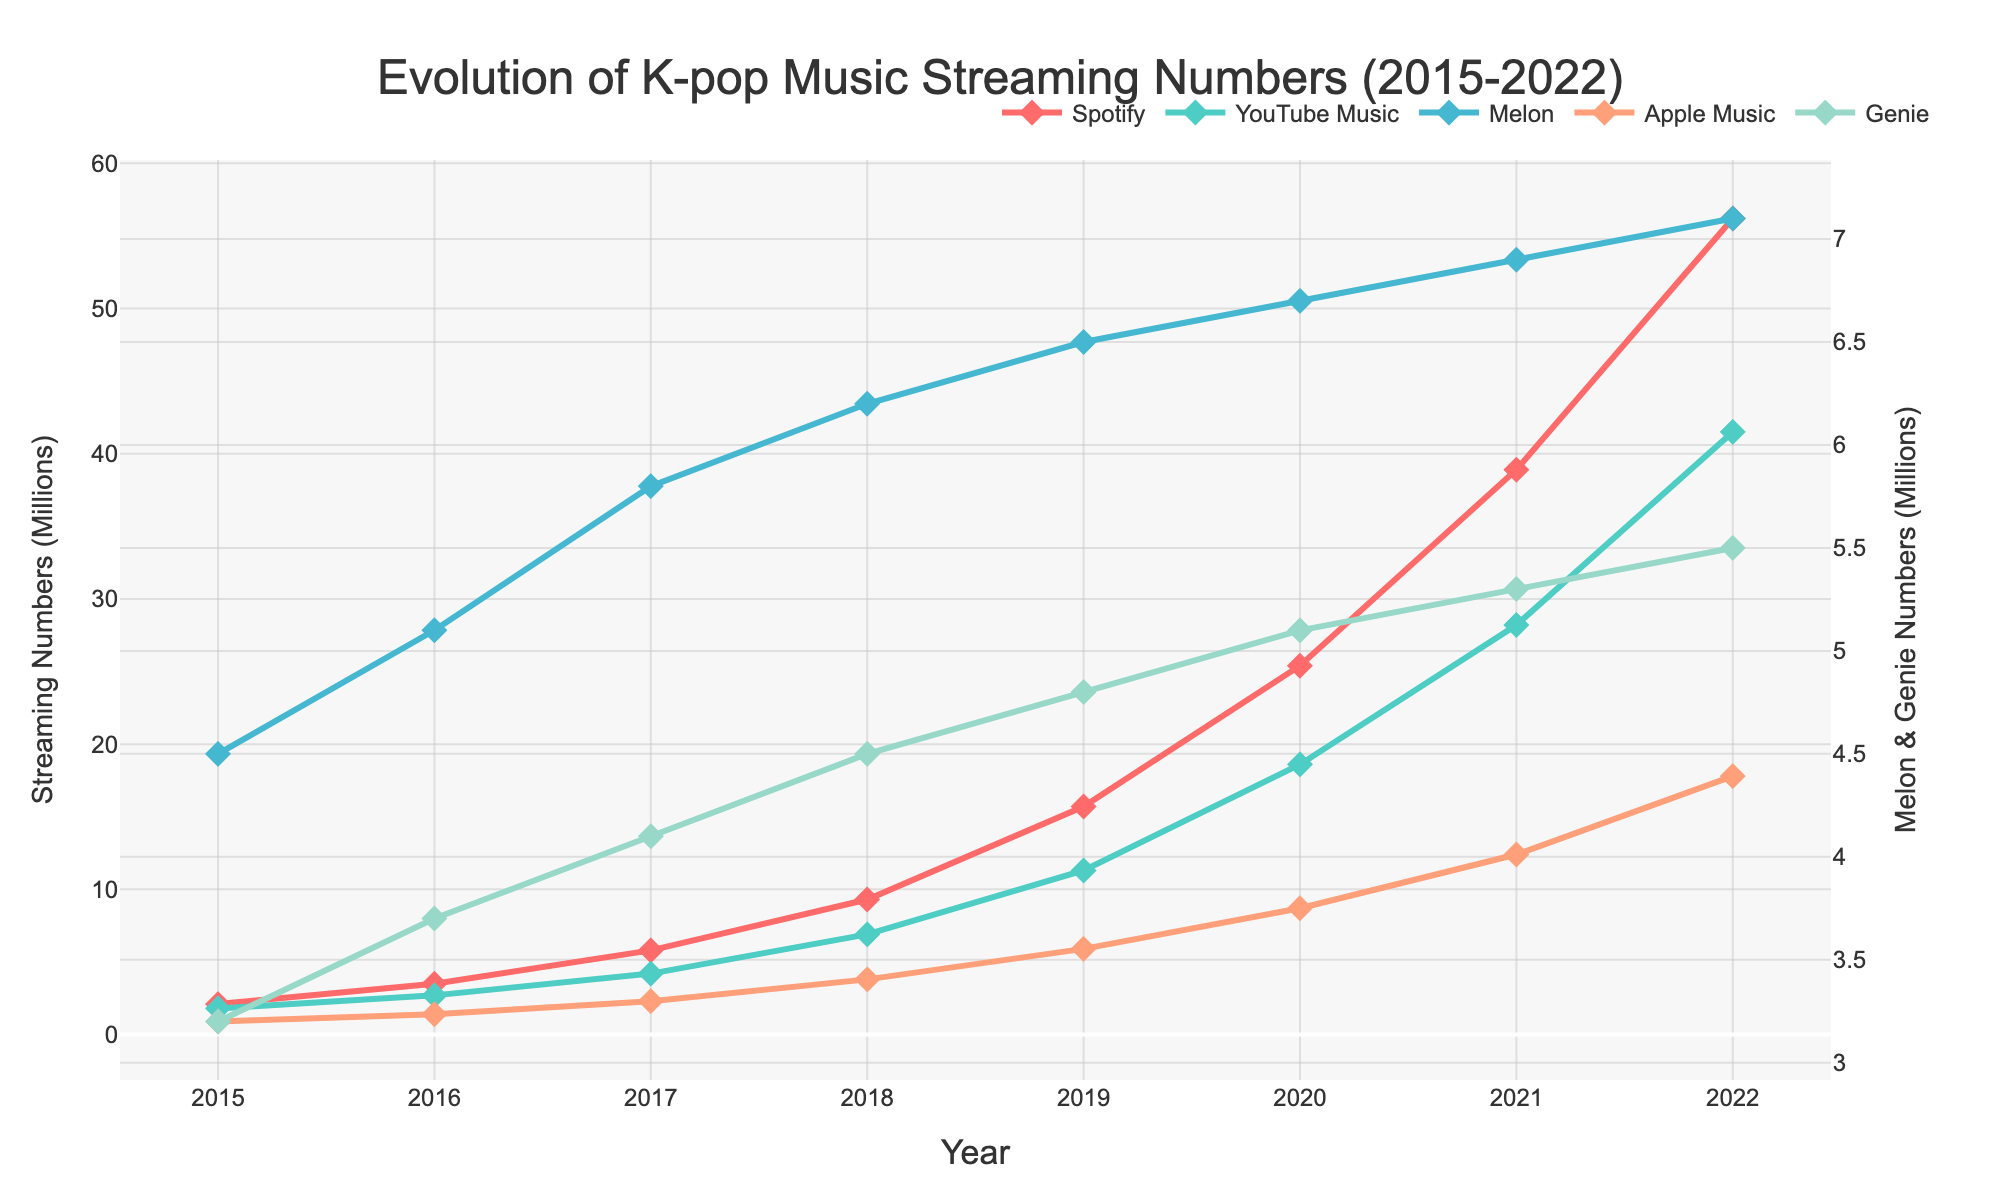Which platform had the highest streaming numbers in 2022? The highest line indicates Spotify with the greatest vertical distance from the x-axis in 2022.
Answer: Spotify How did the streaming numbers for Melon and Genie platforms evolve from 2015 to 2022? Both Melon and Genie experienced relatively stable streaming numbers with mild increases from 2015 to 2022, indicated by their almost horizontal lines.
Answer: Relatively stable Which platform saw the most significant increase in streaming numbers from 2015 to 2022? The line with the steepest upward slope indicates the most significant increase, which is for Spotify.
Answer: Spotify What was the difference in streaming numbers between Spotify and Apple Music in 2022? In 2022, Spotify had 56.2 million while Apple Music had 17.8 million. The difference is 56.2 - 17.8.
Answer: 38.4 million Which year saw the most balanced streaming numbers across all platforms? The year where the lines are closest together indicates a more balanced distribution. This appears to be around 2017, where there is less variance among the lines.
Answer: 2017 Compare the streaming growth patterns of Spotify and YouTube Music. Both platforms show a continuous upward trend, with Spotify having a steeper increase overall. YouTube Music's increase is substantial but less steep.
Answer: Both increased; Spotify steeper What is the average streaming number for Genie over the period presented? Summing Genie's numbers (3.2 + 3.7 + 4.1 + 4.5 + 4.8 + 5.1 + 5.3 + 5.5) and dividing by 8 gives the average. (3.2 + 3.7 + 4.1 + 4.5 + 4.8 + 5.1 + 5.3 + 5.5) / 8 ≈ 4.775
Answer: 4.78 million How do Spotify's streaming numbers in 2017 compare to those of Melon in 2022? In 2017, Spotify had 5.8 million streaming numbers, and Melon had 7.1 million in 2022. Thus, Melon's 2022 numbers are higher.
Answer: Melon is higher in 2022 